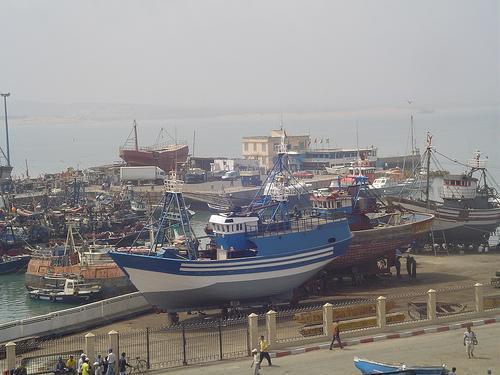How many people are standing under the red boat?
Give a very brief answer. 3. How many boats can you see?
Give a very brief answer. 5. 